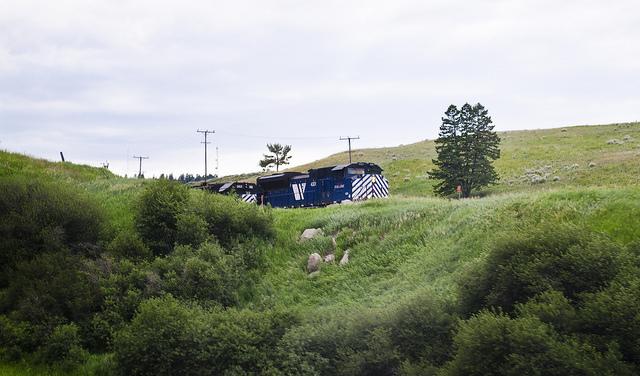How many boulders?
Be succinct. 4. What kind of train is this?
Concise answer only. Freight. Will the train startle the sheep?
Be succinct. Yes. What is coming out of the train on the top?
Short answer required. Smoke. Are there any clouds in the sky?
Answer briefly. Yes. Is that a real train?
Keep it brief. Yes. What is the season?
Concise answer only. Spring. What is the train going over?
Give a very brief answer. Tracks. What sort of terminal would we assume is nearby?
Keep it brief. Train. What is the weather like in this scene?
Give a very brief answer. Cloudy. Is it cloudy?
Quick response, please. Yes. Is this a full size train?
Write a very short answer. Yes. 